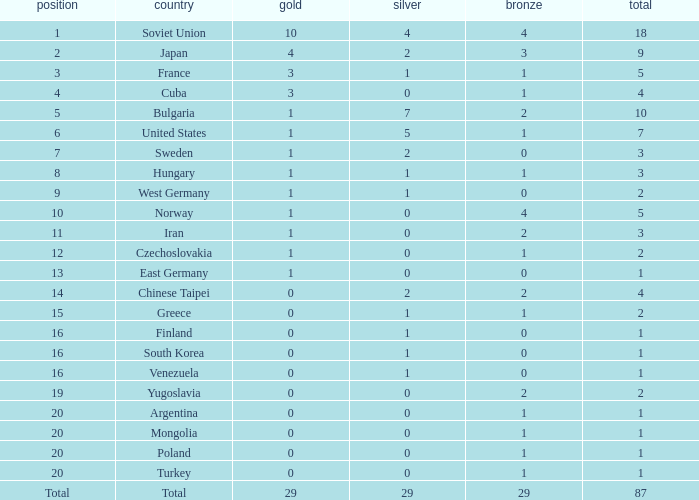What is the sum of gold medals for a rank of 14? 0.0. 